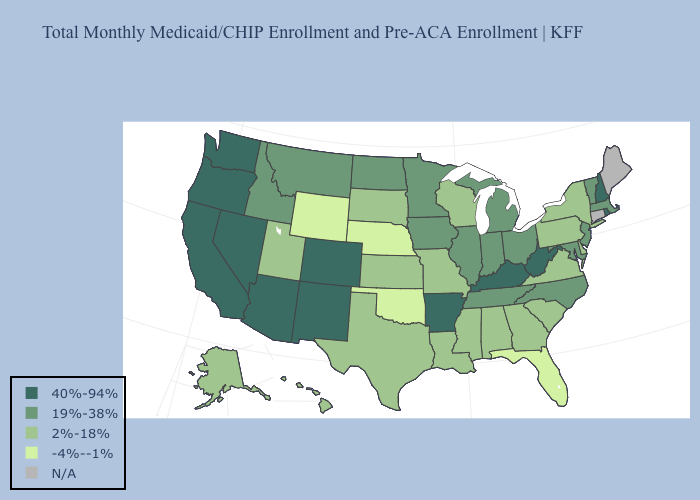What is the lowest value in the West?
Write a very short answer. -4%--1%. Does Oklahoma have the lowest value in the USA?
Give a very brief answer. Yes. What is the highest value in states that border Connecticut?
Quick response, please. 40%-94%. What is the lowest value in the USA?
Give a very brief answer. -4%--1%. What is the value of Maine?
Short answer required. N/A. Among the states that border South Dakota , does North Dakota have the lowest value?
Answer briefly. No. What is the value of Kentucky?
Give a very brief answer. 40%-94%. What is the value of Missouri?
Give a very brief answer. 2%-18%. Does Arizona have the highest value in the West?
Keep it brief. Yes. What is the value of South Dakota?
Be succinct. 2%-18%. What is the value of Nebraska?
Quick response, please. -4%--1%. Name the states that have a value in the range 40%-94%?
Answer briefly. Arizona, Arkansas, California, Colorado, Kentucky, Nevada, New Hampshire, New Mexico, Oregon, Rhode Island, Washington, West Virginia. Does North Carolina have the highest value in the USA?
Give a very brief answer. No. 